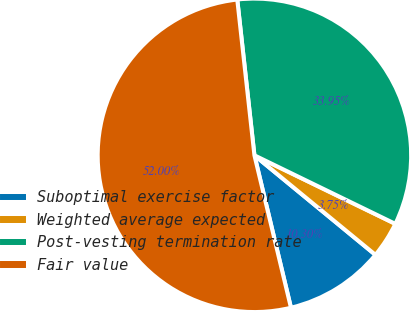Convert chart. <chart><loc_0><loc_0><loc_500><loc_500><pie_chart><fcel>Suboptimal exercise factor<fcel>Weighted average expected<fcel>Post-vesting termination rate<fcel>Fair value<nl><fcel>10.3%<fcel>3.75%<fcel>33.95%<fcel>52.0%<nl></chart> 